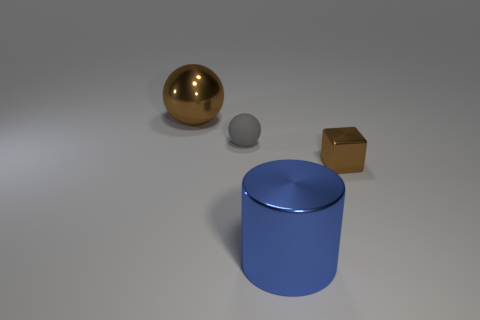Add 3 blue shiny things. How many objects exist? 7 Subtract all cylinders. How many objects are left? 3 Subtract 0 brown cylinders. How many objects are left? 4 Subtract all cyan blocks. Subtract all green cylinders. How many blocks are left? 1 Subtract all big things. Subtract all small cubes. How many objects are left? 1 Add 3 large blue things. How many large blue things are left? 4 Add 4 big green cylinders. How many big green cylinders exist? 4 